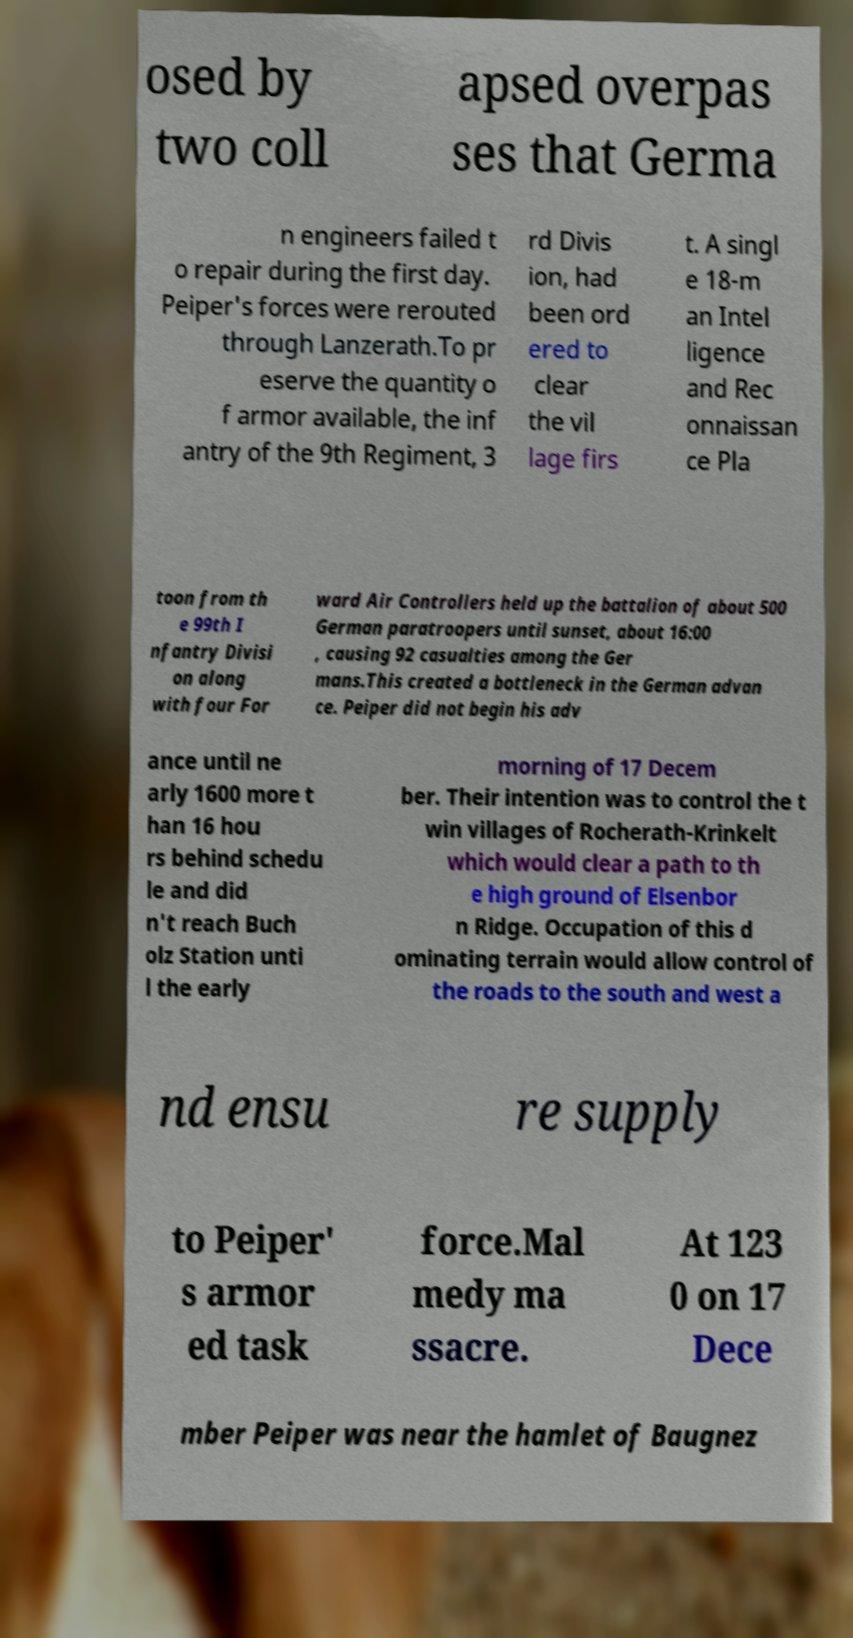Please read and relay the text visible in this image. What does it say? osed by two coll apsed overpas ses that Germa n engineers failed t o repair during the first day. Peiper's forces were rerouted through Lanzerath.To pr eserve the quantity o f armor available, the inf antry of the 9th Regiment, 3 rd Divis ion, had been ord ered to clear the vil lage firs t. A singl e 18-m an Intel ligence and Rec onnaissan ce Pla toon from th e 99th I nfantry Divisi on along with four For ward Air Controllers held up the battalion of about 500 German paratroopers until sunset, about 16:00 , causing 92 casualties among the Ger mans.This created a bottleneck in the German advan ce. Peiper did not begin his adv ance until ne arly 1600 more t han 16 hou rs behind schedu le and did n't reach Buch olz Station unti l the early morning of 17 Decem ber. Their intention was to control the t win villages of Rocherath-Krinkelt which would clear a path to th e high ground of Elsenbor n Ridge. Occupation of this d ominating terrain would allow control of the roads to the south and west a nd ensu re supply to Peiper' s armor ed task force.Mal medy ma ssacre. At 123 0 on 17 Dece mber Peiper was near the hamlet of Baugnez 